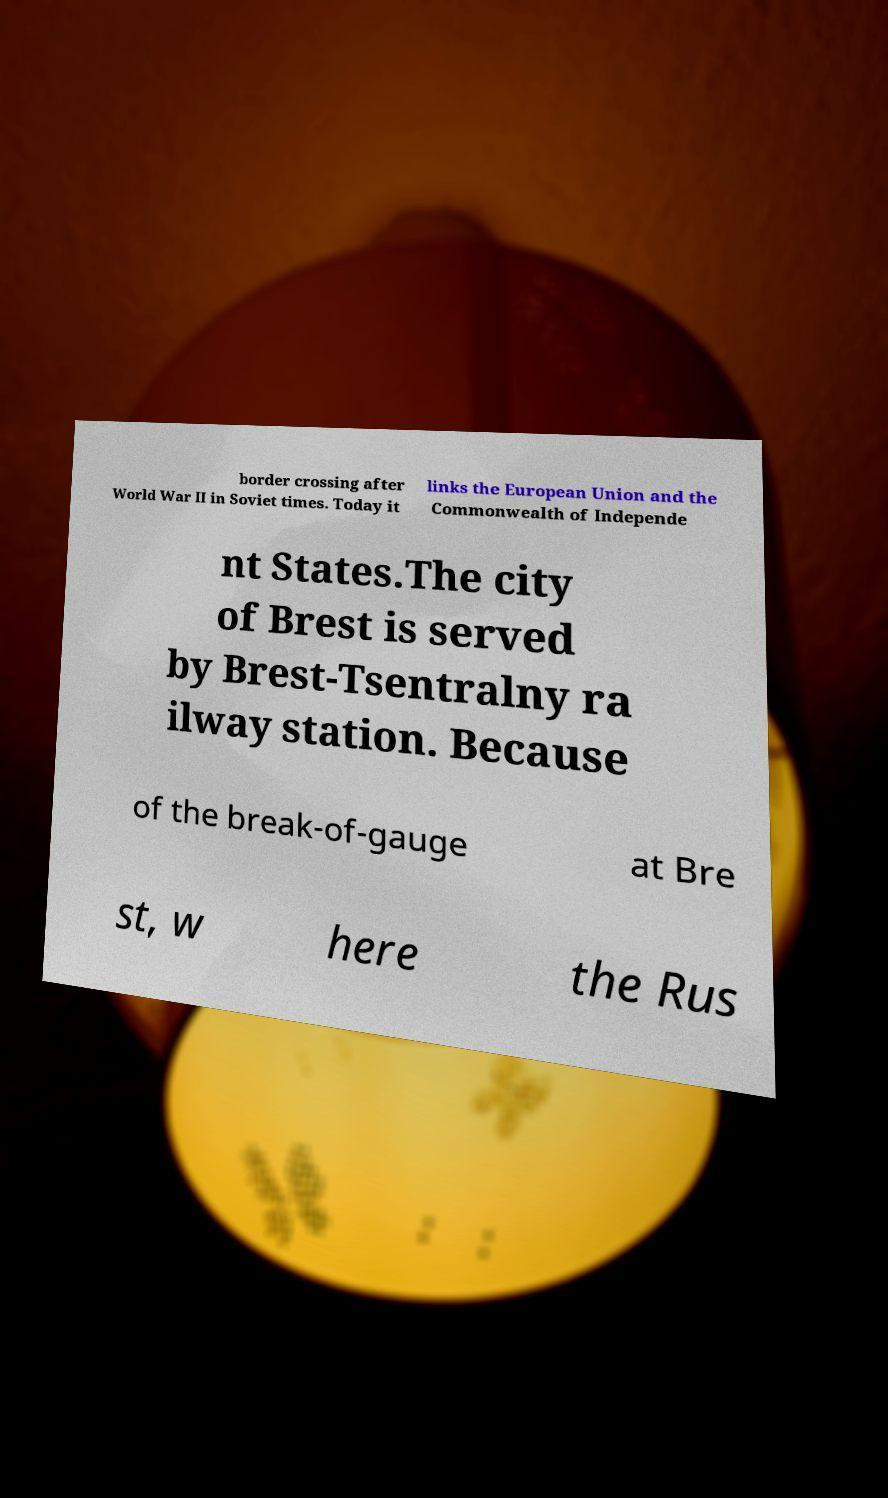Please read and relay the text visible in this image. What does it say? border crossing after World War II in Soviet times. Today it links the European Union and the Commonwealth of Independe nt States.The city of Brest is served by Brest-Tsentralny ra ilway station. Because of the break-of-gauge at Bre st, w here the Rus 